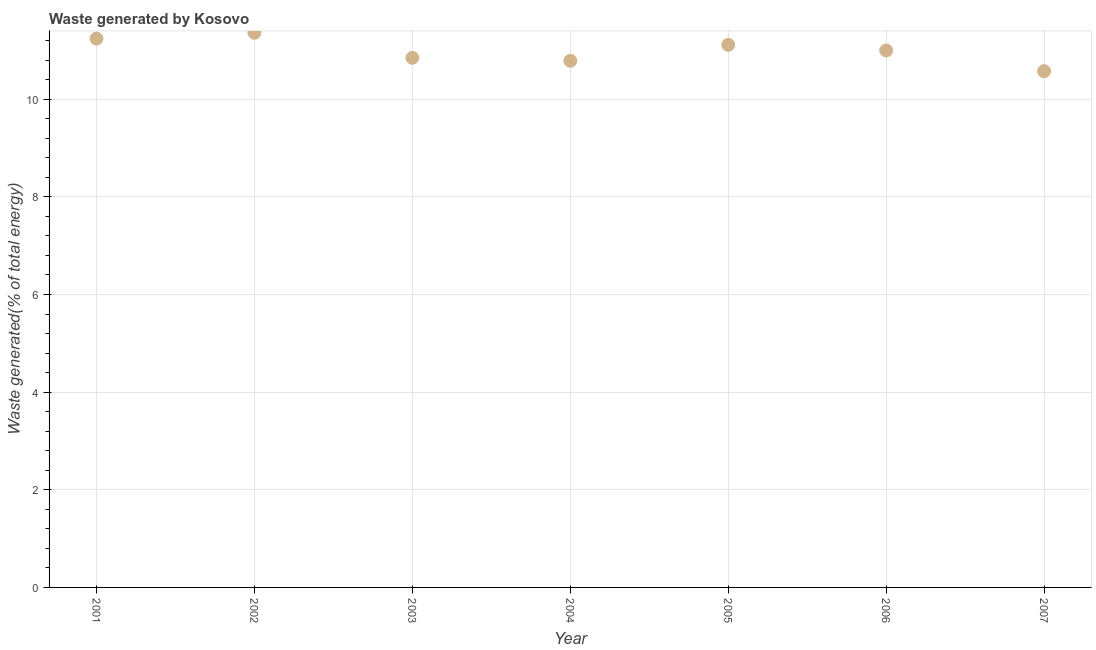What is the amount of waste generated in 2001?
Provide a succinct answer. 11.24. Across all years, what is the maximum amount of waste generated?
Offer a very short reply. 11.36. Across all years, what is the minimum amount of waste generated?
Provide a short and direct response. 10.58. In which year was the amount of waste generated minimum?
Your response must be concise. 2007. What is the sum of the amount of waste generated?
Your response must be concise. 76.93. What is the difference between the amount of waste generated in 2002 and 2005?
Provide a succinct answer. 0.25. What is the average amount of waste generated per year?
Provide a succinct answer. 10.99. What is the median amount of waste generated?
Your answer should be compact. 11. Do a majority of the years between 2001 and 2004 (inclusive) have amount of waste generated greater than 2.4 %?
Your answer should be very brief. Yes. What is the ratio of the amount of waste generated in 2002 to that in 2003?
Your answer should be compact. 1.05. Is the amount of waste generated in 2003 less than that in 2007?
Make the answer very short. No. What is the difference between the highest and the second highest amount of waste generated?
Provide a succinct answer. 0.12. Is the sum of the amount of waste generated in 2001 and 2005 greater than the maximum amount of waste generated across all years?
Your answer should be compact. Yes. What is the difference between the highest and the lowest amount of waste generated?
Ensure brevity in your answer.  0.79. In how many years, is the amount of waste generated greater than the average amount of waste generated taken over all years?
Provide a succinct answer. 4. Does the amount of waste generated monotonically increase over the years?
Provide a succinct answer. No. How many dotlines are there?
Offer a terse response. 1. How many years are there in the graph?
Offer a terse response. 7. Are the values on the major ticks of Y-axis written in scientific E-notation?
Provide a succinct answer. No. Does the graph contain any zero values?
Ensure brevity in your answer.  No. Does the graph contain grids?
Your answer should be very brief. Yes. What is the title of the graph?
Provide a succinct answer. Waste generated by Kosovo. What is the label or title of the X-axis?
Provide a short and direct response. Year. What is the label or title of the Y-axis?
Provide a succinct answer. Waste generated(% of total energy). What is the Waste generated(% of total energy) in 2001?
Your answer should be compact. 11.24. What is the Waste generated(% of total energy) in 2002?
Your response must be concise. 11.36. What is the Waste generated(% of total energy) in 2003?
Provide a short and direct response. 10.85. What is the Waste generated(% of total energy) in 2004?
Your response must be concise. 10.79. What is the Waste generated(% of total energy) in 2005?
Your response must be concise. 11.12. What is the Waste generated(% of total energy) in 2006?
Your answer should be compact. 11. What is the Waste generated(% of total energy) in 2007?
Your answer should be compact. 10.58. What is the difference between the Waste generated(% of total energy) in 2001 and 2002?
Offer a terse response. -0.12. What is the difference between the Waste generated(% of total energy) in 2001 and 2003?
Ensure brevity in your answer.  0.39. What is the difference between the Waste generated(% of total energy) in 2001 and 2004?
Your response must be concise. 0.45. What is the difference between the Waste generated(% of total energy) in 2001 and 2005?
Your answer should be very brief. 0.13. What is the difference between the Waste generated(% of total energy) in 2001 and 2006?
Give a very brief answer. 0.24. What is the difference between the Waste generated(% of total energy) in 2001 and 2007?
Ensure brevity in your answer.  0.67. What is the difference between the Waste generated(% of total energy) in 2002 and 2003?
Make the answer very short. 0.51. What is the difference between the Waste generated(% of total energy) in 2002 and 2004?
Keep it short and to the point. 0.57. What is the difference between the Waste generated(% of total energy) in 2002 and 2005?
Provide a short and direct response. 0.25. What is the difference between the Waste generated(% of total energy) in 2002 and 2006?
Provide a short and direct response. 0.36. What is the difference between the Waste generated(% of total energy) in 2002 and 2007?
Provide a short and direct response. 0.79. What is the difference between the Waste generated(% of total energy) in 2003 and 2004?
Give a very brief answer. 0.06. What is the difference between the Waste generated(% of total energy) in 2003 and 2005?
Ensure brevity in your answer.  -0.27. What is the difference between the Waste generated(% of total energy) in 2003 and 2006?
Offer a terse response. -0.15. What is the difference between the Waste generated(% of total energy) in 2003 and 2007?
Your response must be concise. 0.27. What is the difference between the Waste generated(% of total energy) in 2004 and 2005?
Offer a very short reply. -0.33. What is the difference between the Waste generated(% of total energy) in 2004 and 2006?
Keep it short and to the point. -0.21. What is the difference between the Waste generated(% of total energy) in 2004 and 2007?
Give a very brief answer. 0.21. What is the difference between the Waste generated(% of total energy) in 2005 and 2006?
Your answer should be compact. 0.12. What is the difference between the Waste generated(% of total energy) in 2005 and 2007?
Give a very brief answer. 0.54. What is the difference between the Waste generated(% of total energy) in 2006 and 2007?
Make the answer very short. 0.42. What is the ratio of the Waste generated(% of total energy) in 2001 to that in 2002?
Provide a short and direct response. 0.99. What is the ratio of the Waste generated(% of total energy) in 2001 to that in 2003?
Your answer should be very brief. 1.04. What is the ratio of the Waste generated(% of total energy) in 2001 to that in 2004?
Make the answer very short. 1.04. What is the ratio of the Waste generated(% of total energy) in 2001 to that in 2007?
Offer a very short reply. 1.06. What is the ratio of the Waste generated(% of total energy) in 2002 to that in 2003?
Provide a short and direct response. 1.05. What is the ratio of the Waste generated(% of total energy) in 2002 to that in 2004?
Give a very brief answer. 1.05. What is the ratio of the Waste generated(% of total energy) in 2002 to that in 2005?
Keep it short and to the point. 1.02. What is the ratio of the Waste generated(% of total energy) in 2002 to that in 2006?
Offer a very short reply. 1.03. What is the ratio of the Waste generated(% of total energy) in 2002 to that in 2007?
Offer a terse response. 1.07. What is the ratio of the Waste generated(% of total energy) in 2003 to that in 2004?
Make the answer very short. 1.01. What is the ratio of the Waste generated(% of total energy) in 2003 to that in 2007?
Provide a short and direct response. 1.03. What is the ratio of the Waste generated(% of total energy) in 2004 to that in 2005?
Give a very brief answer. 0.97. What is the ratio of the Waste generated(% of total energy) in 2004 to that in 2006?
Ensure brevity in your answer.  0.98. What is the ratio of the Waste generated(% of total energy) in 2004 to that in 2007?
Offer a terse response. 1.02. What is the ratio of the Waste generated(% of total energy) in 2005 to that in 2006?
Ensure brevity in your answer.  1.01. What is the ratio of the Waste generated(% of total energy) in 2005 to that in 2007?
Your answer should be very brief. 1.05. What is the ratio of the Waste generated(% of total energy) in 2006 to that in 2007?
Provide a short and direct response. 1.04. 